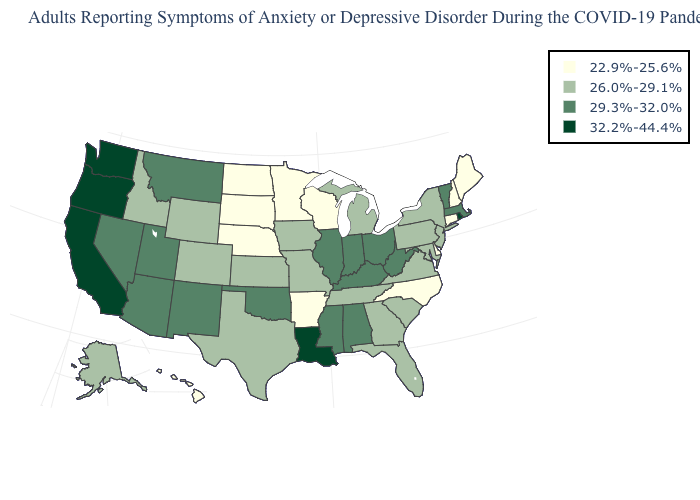What is the value of Connecticut?
Be succinct. 22.9%-25.6%. What is the value of Maine?
Quick response, please. 22.9%-25.6%. Name the states that have a value in the range 26.0%-29.1%?
Keep it brief. Alaska, Colorado, Florida, Georgia, Idaho, Iowa, Kansas, Maryland, Michigan, Missouri, New Jersey, New York, Pennsylvania, South Carolina, Tennessee, Texas, Virginia, Wyoming. Does Oregon have the highest value in the USA?
Answer briefly. Yes. Name the states that have a value in the range 32.2%-44.4%?
Give a very brief answer. California, Louisiana, Oregon, Rhode Island, Washington. Name the states that have a value in the range 26.0%-29.1%?
Keep it brief. Alaska, Colorado, Florida, Georgia, Idaho, Iowa, Kansas, Maryland, Michigan, Missouri, New Jersey, New York, Pennsylvania, South Carolina, Tennessee, Texas, Virginia, Wyoming. Does Washington have a lower value than Nebraska?
Short answer required. No. Name the states that have a value in the range 29.3%-32.0%?
Keep it brief. Alabama, Arizona, Illinois, Indiana, Kentucky, Massachusetts, Mississippi, Montana, Nevada, New Mexico, Ohio, Oklahoma, Utah, Vermont, West Virginia. Among the states that border Pennsylvania , does Delaware have the lowest value?
Quick response, please. Yes. What is the value of Colorado?
Short answer required. 26.0%-29.1%. Among the states that border Arizona , does Utah have the highest value?
Give a very brief answer. No. Does Wisconsin have a lower value than Maine?
Short answer required. No. What is the value of Connecticut?
Give a very brief answer. 22.9%-25.6%. Which states have the highest value in the USA?
Be succinct. California, Louisiana, Oregon, Rhode Island, Washington. What is the highest value in states that border West Virginia?
Quick response, please. 29.3%-32.0%. 